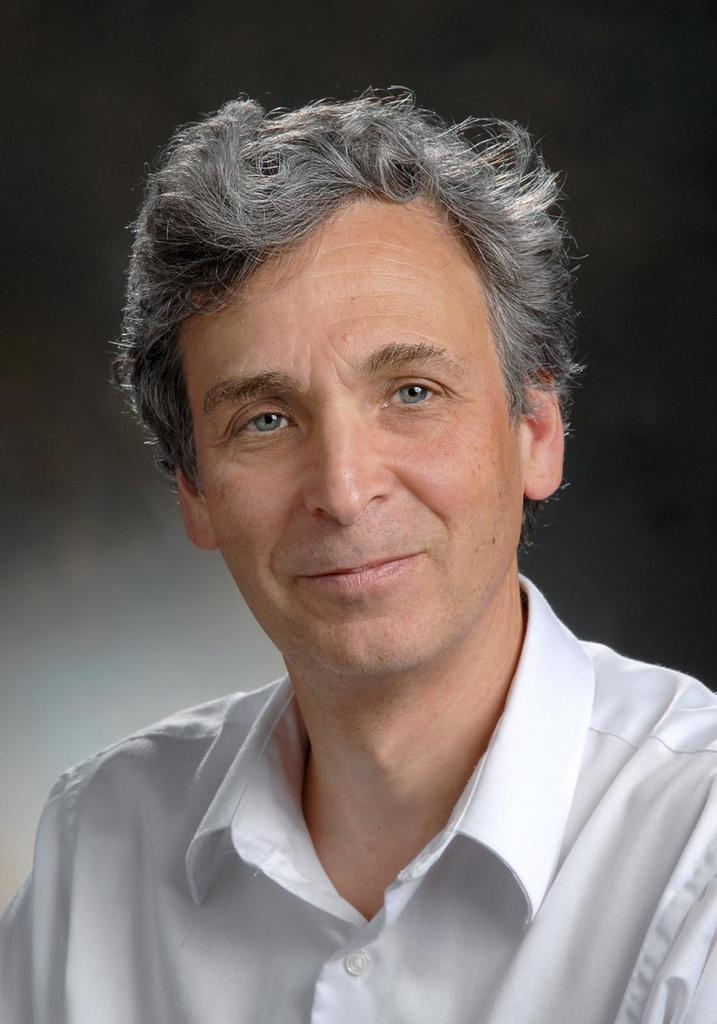What is the main subject of the image? There is a person in the image. What expression does the person have? The person is smiling. Can you describe the background of the image? The background of the image is blurry. What type of jelly can be seen on the floor in the image? There is no jelly present in the image. What is the color of the drop on the person's shoulder in the image? There is no drop visible on the person's shoulder in the image. 